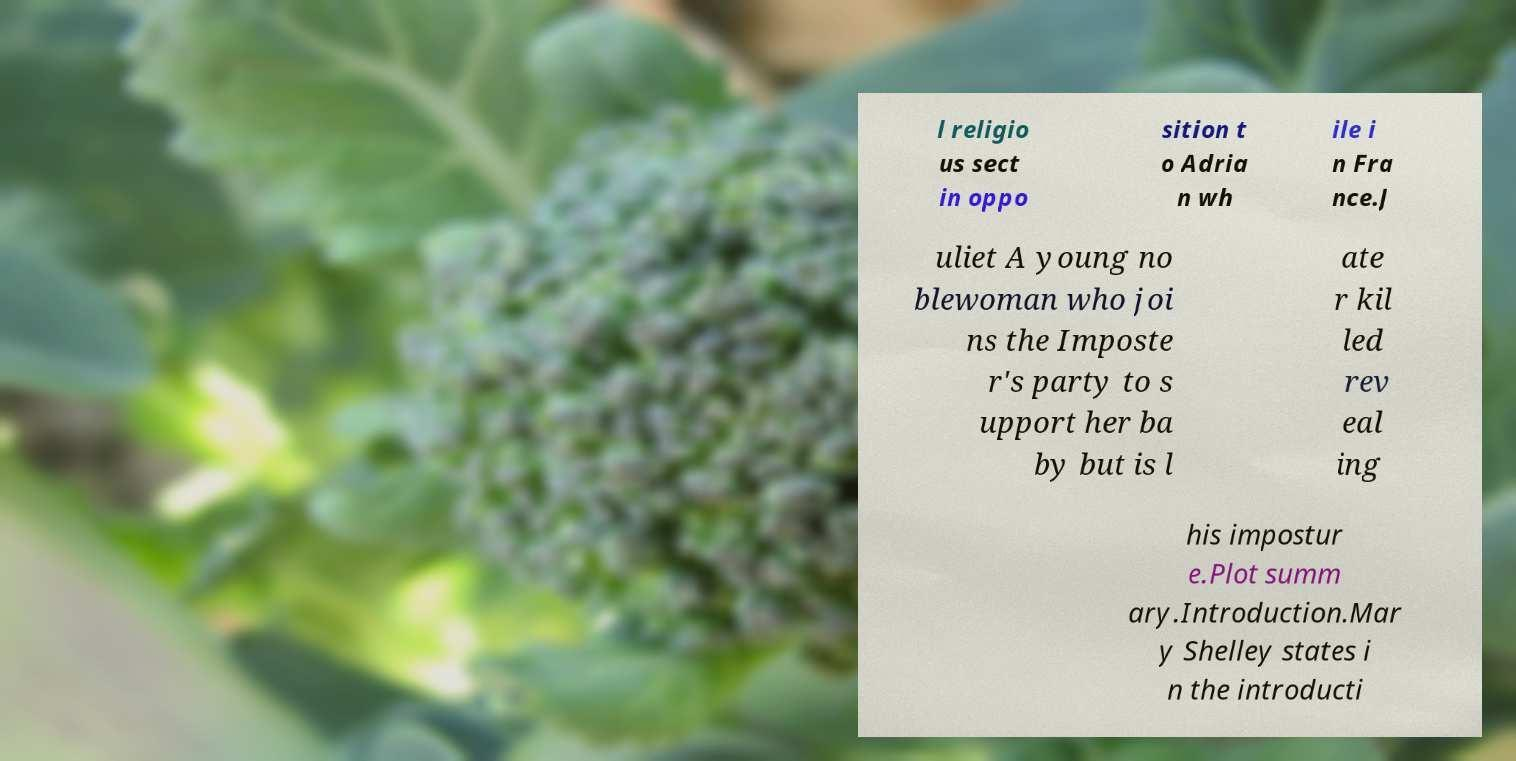Can you accurately transcribe the text from the provided image for me? l religio us sect in oppo sition t o Adria n wh ile i n Fra nce.J uliet A young no blewoman who joi ns the Imposte r's party to s upport her ba by but is l ate r kil led rev eal ing his impostur e.Plot summ ary.Introduction.Mar y Shelley states i n the introducti 